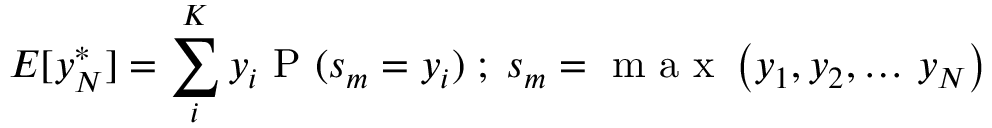<formula> <loc_0><loc_0><loc_500><loc_500>E [ y _ { N } ^ { * } ] = \sum _ { i } ^ { K } y _ { i } P ( s _ { m } = y _ { i } ) \, ; \, s _ { m } = \max \left ( y _ { 1 } , y _ { 2 } , \dots \, y _ { N } \right )</formula> 